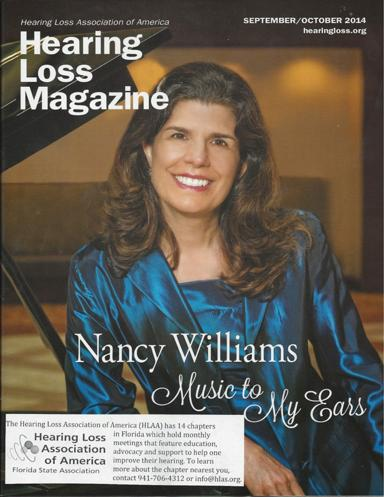What organization is associated with the magazine? The magazine is published by the Hearing Loss Association of America, an organization committed to helping people with hearing loss through advocacy, education, and community support. 